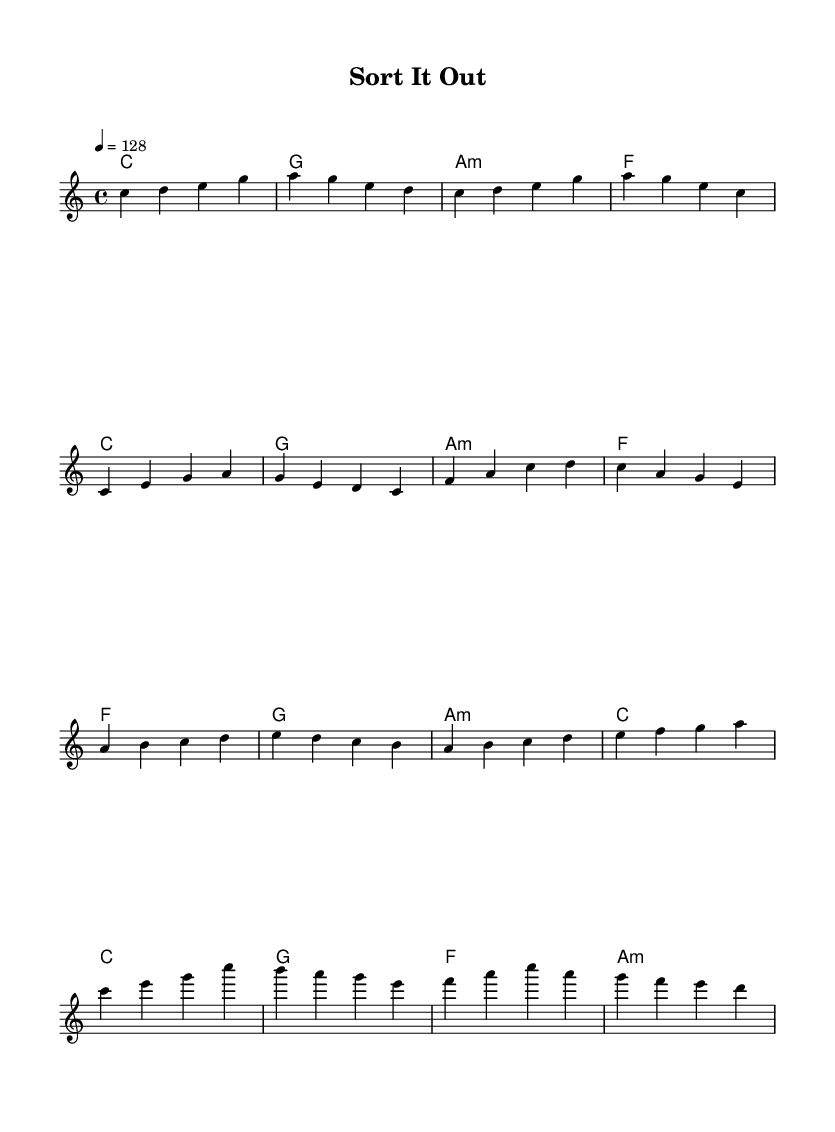What is the key signature of this music? The key signature is indicated at the beginning of the score, showing that it is in C major, which has no sharps or flats.
Answer: C major What is the time signature of this music? The time signature is found right after the key signature at the start, showing that the music is in 4/4 time, meaning there are four beats in each measure.
Answer: 4/4 What is the tempo marking of this music? The tempo is specified in the score as "4 = 128", meaning there are 128 beats per minute, indicating a lively pace.
Answer: 128 What is the main theme of the chorus? The chorus consists of a melody that features the notes C, E, G, C, B, A, G, E, F, A, C, A, G, F, E, D, suggesting an uplifting and energetic theme.
Answer: Uplifting How many measures are in the pre-chorus section? The pre-chorus consists of four measures, each containing a specific chord structure that contributes to the buildup leading into the chorus.
Answer: 4 Which chord is used most frequently in the verse section? Analyzing the verse section reveals that the chord C major is repeated most frequently, established in the harmonic progression of the melody.
Answer: C What is a typical characteristic of K-Pop music reflected in this sheet? The sheet music showcases an energetic and catchy melody with a strong rhythmic drive and structured sections, typical of K-Pop's design for appealing hooks and choruses.
Answer: Energetic 